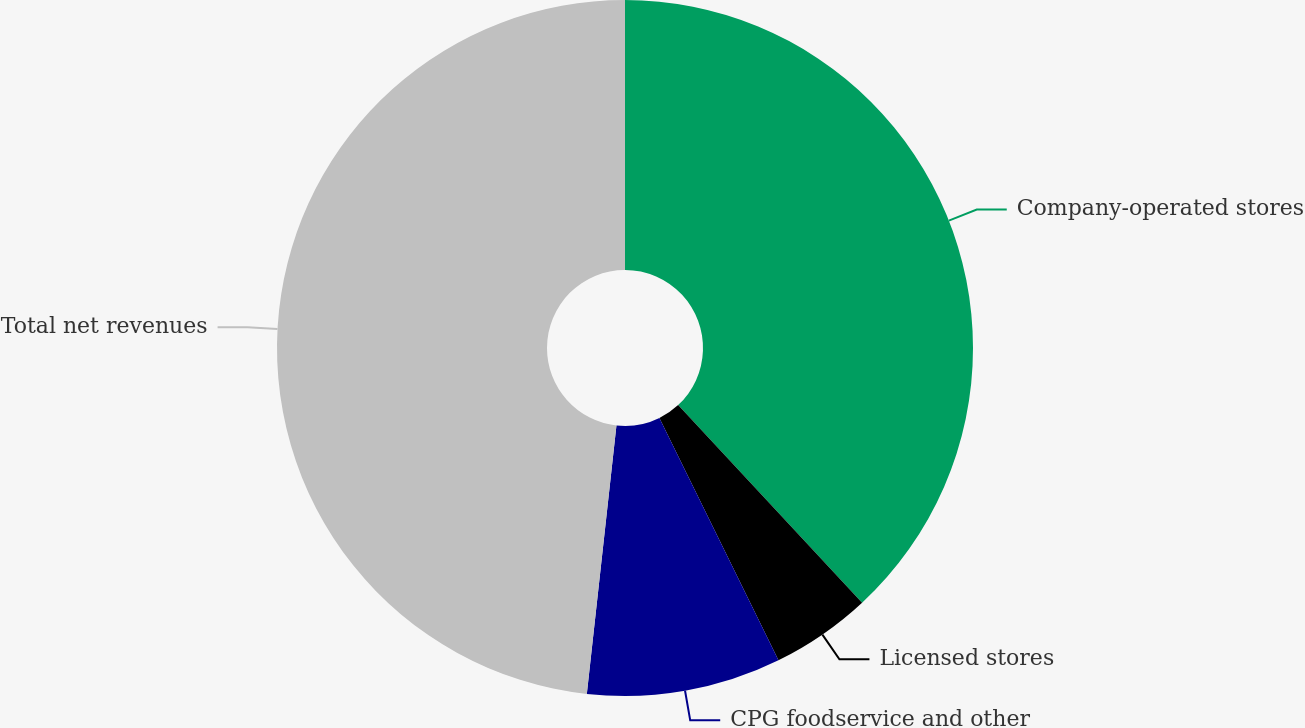Convert chart. <chart><loc_0><loc_0><loc_500><loc_500><pie_chart><fcel>Company-operated stores<fcel>Licensed stores<fcel>CPG foodservice and other<fcel>Total net revenues<nl><fcel>38.07%<fcel>4.66%<fcel>9.02%<fcel>48.25%<nl></chart> 